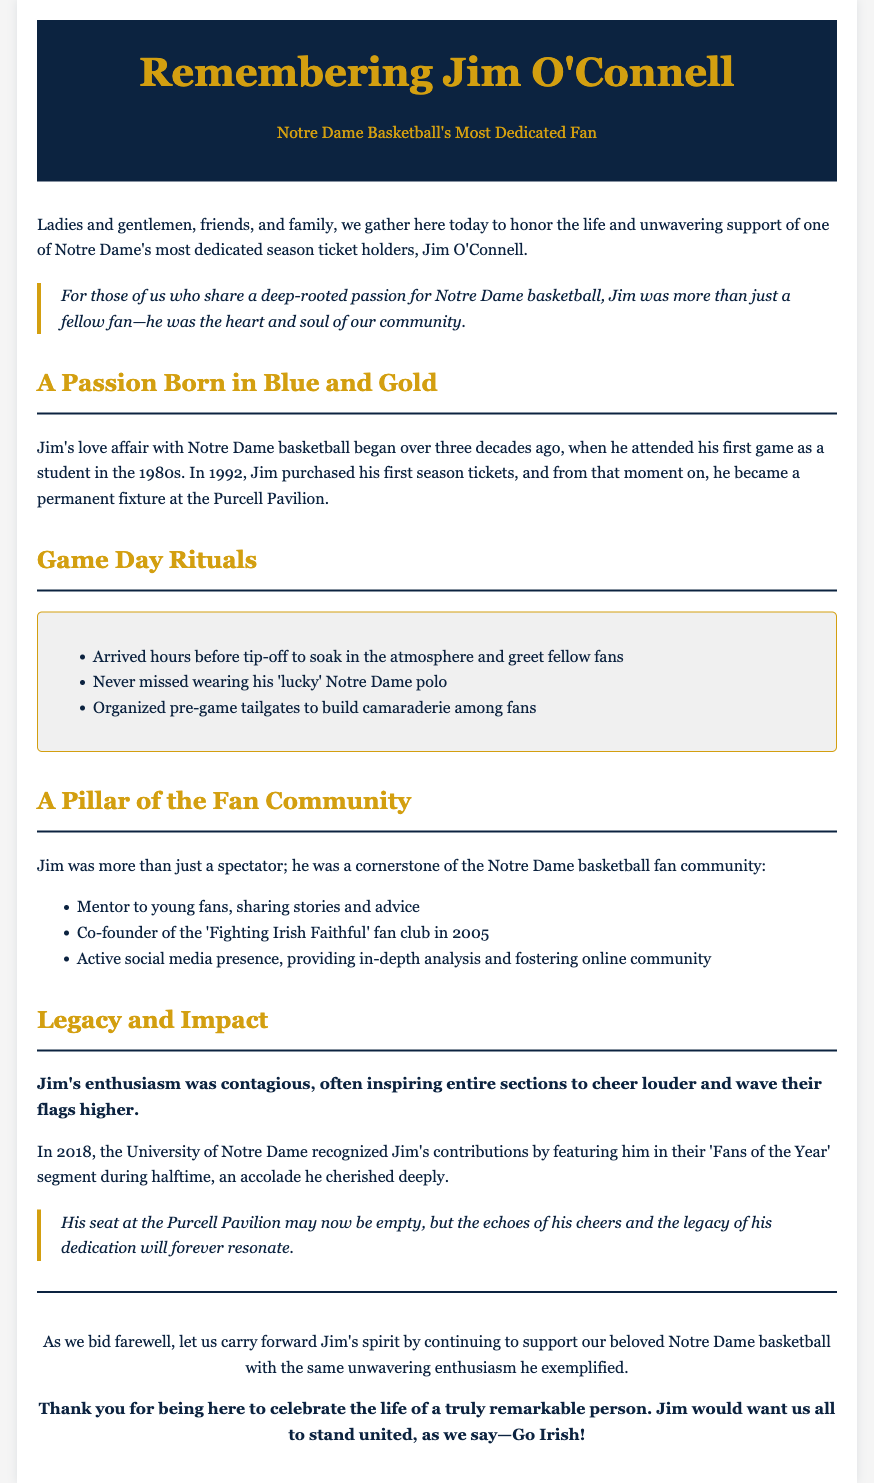What year did Jim O'Connell purchase his first season tickets? The document states that Jim purchased his first season tickets in 1992.
Answer: 1992 What was Jim's lucky apparel on game days? The eulogy mentions that Jim never missed wearing his 'lucky' Notre Dame polo.
Answer: Notre Dame polo What fan club did Jim co-found? According to the document, Jim co-founded the 'Fighting Irish Faithful' fan club in 2005.
Answer: Fighting Irish Faithful In what year was Jim recognized as a 'Fan of the Year'? The document indicates that Jim was recognized in 2018.
Answer: 2018 How long did Jim's love for Notre Dame basketball span? The text mentions that Jim's love affair with Notre Dame basketball began over three decades ago, specifically since the 1980s.
Answer: Over three decades What was one of Jim's pre-game rituals? The eulogy lists that Jim organized pre-game tailgates to build camaraderie among fans as one of his rituals.
Answer: Organized pre-game tailgates What impact did Jim's enthusiasm have on fellow fans? The document describes that Jim's enthusiasm was contagious, inspiring others to cheer louder.
Answer: Contagious What sentiment does the eulogy convey about Jim's seat at Purcell Pavilion? The eulogy notes that Jim's seat may now be empty, but his legacy will resonate.
Answer: Empty seat, legacy will resonate 